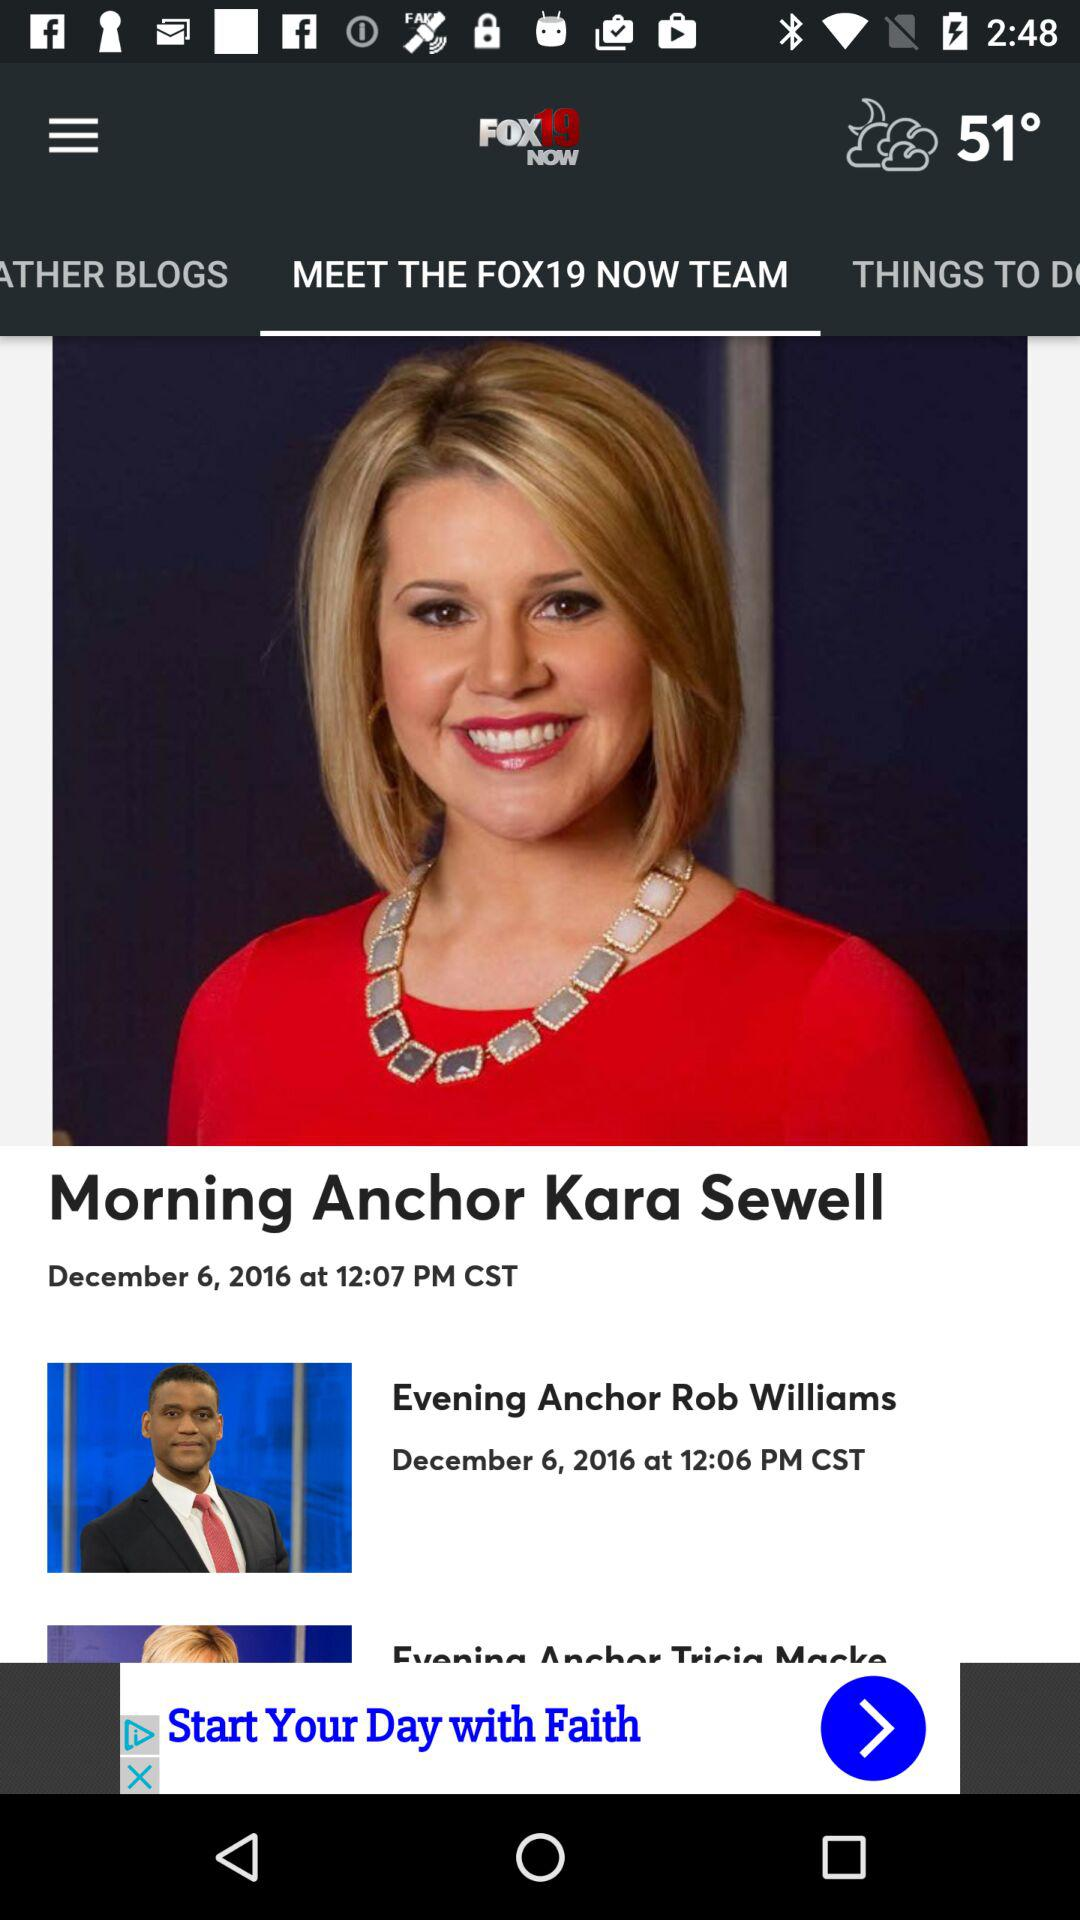At what time was the news "Morning Anchor Kara Sewell" posted? The news was posted at 12:07 PM CST. 